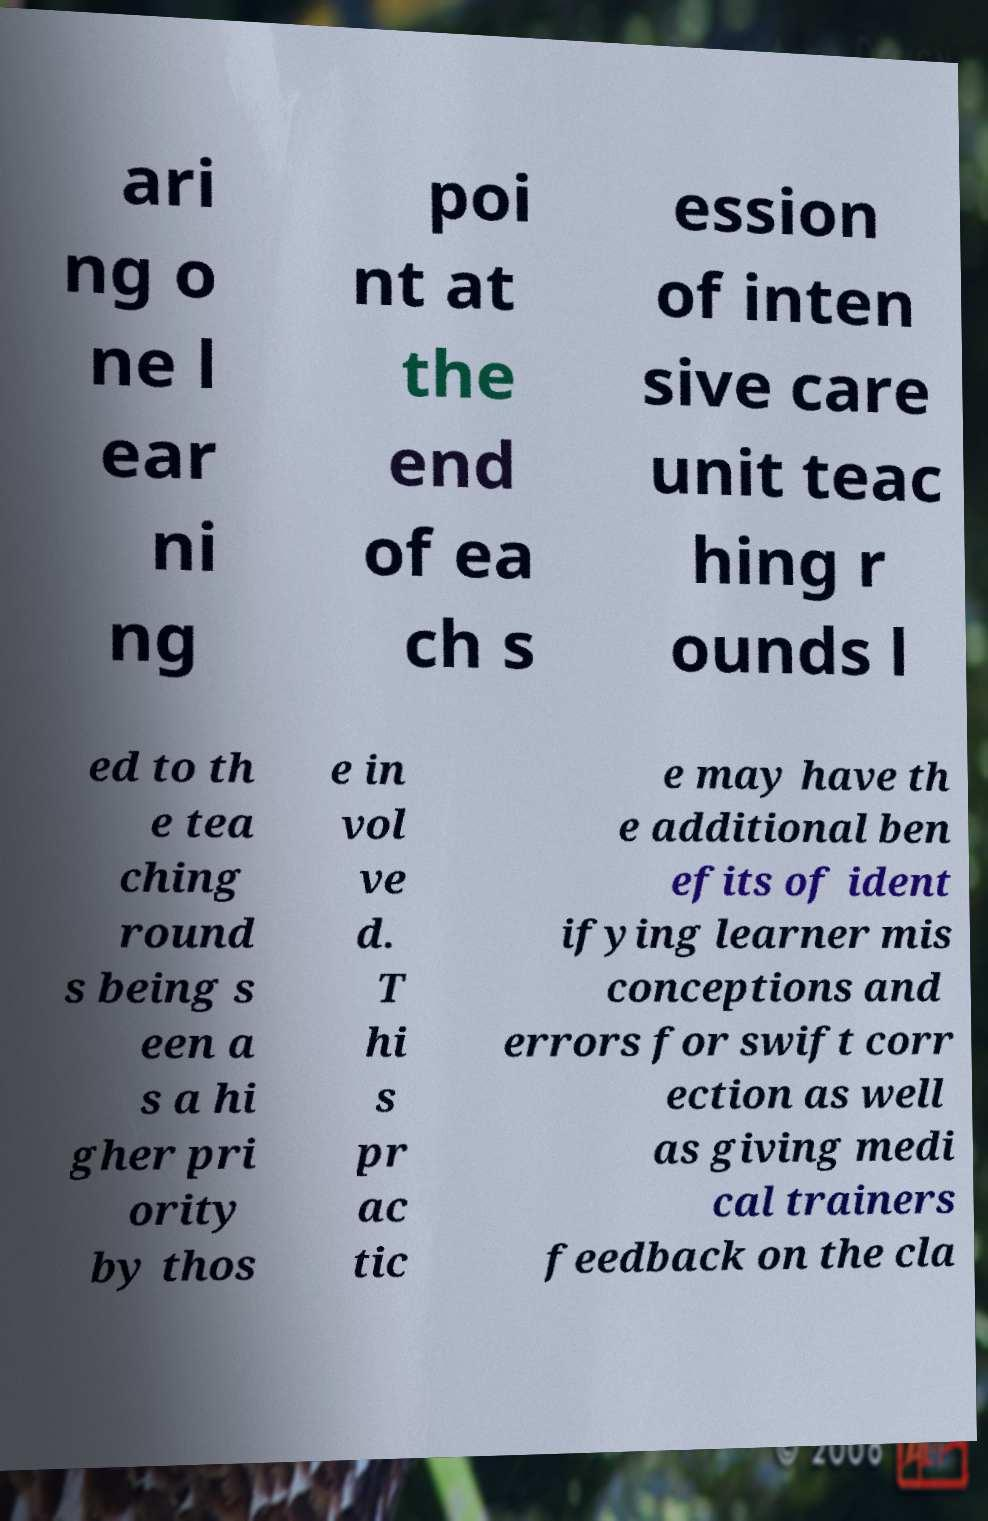Please identify and transcribe the text found in this image. ari ng o ne l ear ni ng poi nt at the end of ea ch s ession of inten sive care unit teac hing r ounds l ed to th e tea ching round s being s een a s a hi gher pri ority by thos e in vol ve d. T hi s pr ac tic e may have th e additional ben efits of ident ifying learner mis conceptions and errors for swift corr ection as well as giving medi cal trainers feedback on the cla 